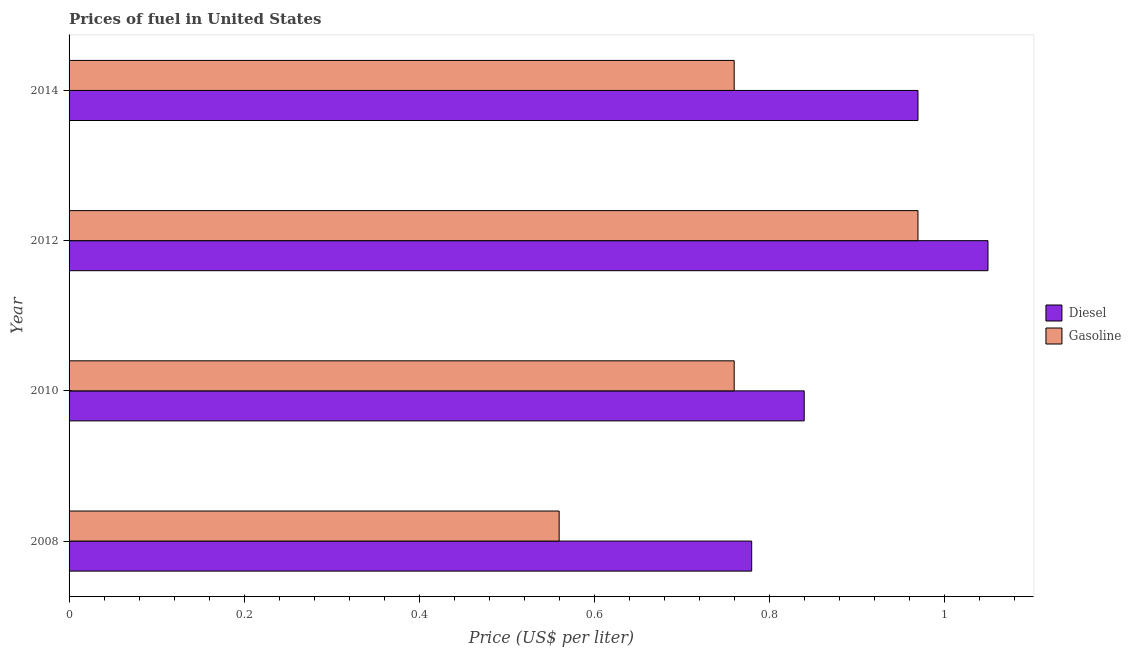How many different coloured bars are there?
Ensure brevity in your answer.  2. How many bars are there on the 2nd tick from the top?
Your answer should be compact. 2. How many bars are there on the 1st tick from the bottom?
Your answer should be compact. 2. What is the label of the 3rd group of bars from the top?
Provide a succinct answer. 2010. In how many cases, is the number of bars for a given year not equal to the number of legend labels?
Ensure brevity in your answer.  0. What is the diesel price in 2008?
Your response must be concise. 0.78. Across all years, what is the minimum diesel price?
Offer a terse response. 0.78. In which year was the gasoline price maximum?
Provide a short and direct response. 2012. In which year was the diesel price minimum?
Give a very brief answer. 2008. What is the total gasoline price in the graph?
Provide a succinct answer. 3.05. What is the difference between the diesel price in 2008 and that in 2010?
Your answer should be compact. -0.06. What is the difference between the diesel price in 2008 and the gasoline price in 2014?
Your answer should be compact. 0.02. What is the average gasoline price per year?
Your response must be concise. 0.76. In the year 2008, what is the difference between the diesel price and gasoline price?
Provide a short and direct response. 0.22. In how many years, is the diesel price greater than 0.36 US$ per litre?
Ensure brevity in your answer.  4. What is the ratio of the diesel price in 2012 to that in 2014?
Give a very brief answer. 1.08. Is the gasoline price in 2008 less than that in 2010?
Offer a very short reply. Yes. Is the difference between the diesel price in 2012 and 2014 greater than the difference between the gasoline price in 2012 and 2014?
Keep it short and to the point. No. What is the difference between the highest and the second highest gasoline price?
Keep it short and to the point. 0.21. What is the difference between the highest and the lowest diesel price?
Your answer should be compact. 0.27. Is the sum of the diesel price in 2008 and 2010 greater than the maximum gasoline price across all years?
Provide a succinct answer. Yes. What does the 1st bar from the top in 2008 represents?
Offer a very short reply. Gasoline. What does the 2nd bar from the bottom in 2012 represents?
Your answer should be compact. Gasoline. How many bars are there?
Give a very brief answer. 8. How many years are there in the graph?
Your response must be concise. 4. Does the graph contain any zero values?
Keep it short and to the point. No. Does the graph contain grids?
Offer a terse response. No. What is the title of the graph?
Your response must be concise. Prices of fuel in United States. Does "Female labor force" appear as one of the legend labels in the graph?
Offer a very short reply. No. What is the label or title of the X-axis?
Your response must be concise. Price (US$ per liter). What is the Price (US$ per liter) of Diesel in 2008?
Provide a succinct answer. 0.78. What is the Price (US$ per liter) of Gasoline in 2008?
Ensure brevity in your answer.  0.56. What is the Price (US$ per liter) of Diesel in 2010?
Provide a succinct answer. 0.84. What is the Price (US$ per liter) in Gasoline in 2010?
Ensure brevity in your answer.  0.76. What is the Price (US$ per liter) in Diesel in 2012?
Offer a very short reply. 1.05. What is the Price (US$ per liter) of Gasoline in 2014?
Offer a very short reply. 0.76. Across all years, what is the maximum Price (US$ per liter) in Diesel?
Provide a succinct answer. 1.05. Across all years, what is the minimum Price (US$ per liter) of Diesel?
Give a very brief answer. 0.78. Across all years, what is the minimum Price (US$ per liter) of Gasoline?
Your response must be concise. 0.56. What is the total Price (US$ per liter) of Diesel in the graph?
Provide a succinct answer. 3.64. What is the total Price (US$ per liter) in Gasoline in the graph?
Your response must be concise. 3.05. What is the difference between the Price (US$ per liter) in Diesel in 2008 and that in 2010?
Offer a very short reply. -0.06. What is the difference between the Price (US$ per liter) in Gasoline in 2008 and that in 2010?
Keep it short and to the point. -0.2. What is the difference between the Price (US$ per liter) of Diesel in 2008 and that in 2012?
Your response must be concise. -0.27. What is the difference between the Price (US$ per liter) of Gasoline in 2008 and that in 2012?
Your response must be concise. -0.41. What is the difference between the Price (US$ per liter) of Diesel in 2008 and that in 2014?
Offer a very short reply. -0.19. What is the difference between the Price (US$ per liter) in Diesel in 2010 and that in 2012?
Ensure brevity in your answer.  -0.21. What is the difference between the Price (US$ per liter) in Gasoline in 2010 and that in 2012?
Your answer should be compact. -0.21. What is the difference between the Price (US$ per liter) in Diesel in 2010 and that in 2014?
Your answer should be very brief. -0.13. What is the difference between the Price (US$ per liter) of Gasoline in 2010 and that in 2014?
Provide a succinct answer. 0. What is the difference between the Price (US$ per liter) in Diesel in 2012 and that in 2014?
Provide a succinct answer. 0.08. What is the difference between the Price (US$ per liter) in Gasoline in 2012 and that in 2014?
Offer a terse response. 0.21. What is the difference between the Price (US$ per liter) in Diesel in 2008 and the Price (US$ per liter) in Gasoline in 2012?
Offer a terse response. -0.19. What is the difference between the Price (US$ per liter) of Diesel in 2010 and the Price (US$ per liter) of Gasoline in 2012?
Your response must be concise. -0.13. What is the difference between the Price (US$ per liter) of Diesel in 2010 and the Price (US$ per liter) of Gasoline in 2014?
Provide a succinct answer. 0.08. What is the difference between the Price (US$ per liter) of Diesel in 2012 and the Price (US$ per liter) of Gasoline in 2014?
Your answer should be compact. 0.29. What is the average Price (US$ per liter) in Diesel per year?
Your answer should be compact. 0.91. What is the average Price (US$ per liter) in Gasoline per year?
Offer a very short reply. 0.76. In the year 2008, what is the difference between the Price (US$ per liter) of Diesel and Price (US$ per liter) of Gasoline?
Offer a very short reply. 0.22. In the year 2010, what is the difference between the Price (US$ per liter) in Diesel and Price (US$ per liter) in Gasoline?
Offer a terse response. 0.08. In the year 2012, what is the difference between the Price (US$ per liter) of Diesel and Price (US$ per liter) of Gasoline?
Offer a terse response. 0.08. In the year 2014, what is the difference between the Price (US$ per liter) of Diesel and Price (US$ per liter) of Gasoline?
Give a very brief answer. 0.21. What is the ratio of the Price (US$ per liter) of Gasoline in 2008 to that in 2010?
Keep it short and to the point. 0.74. What is the ratio of the Price (US$ per liter) in Diesel in 2008 to that in 2012?
Provide a succinct answer. 0.74. What is the ratio of the Price (US$ per liter) in Gasoline in 2008 to that in 2012?
Give a very brief answer. 0.58. What is the ratio of the Price (US$ per liter) of Diesel in 2008 to that in 2014?
Your answer should be very brief. 0.8. What is the ratio of the Price (US$ per liter) in Gasoline in 2008 to that in 2014?
Offer a very short reply. 0.74. What is the ratio of the Price (US$ per liter) of Diesel in 2010 to that in 2012?
Your answer should be compact. 0.8. What is the ratio of the Price (US$ per liter) of Gasoline in 2010 to that in 2012?
Provide a succinct answer. 0.78. What is the ratio of the Price (US$ per liter) in Diesel in 2010 to that in 2014?
Keep it short and to the point. 0.87. What is the ratio of the Price (US$ per liter) of Gasoline in 2010 to that in 2014?
Provide a succinct answer. 1. What is the ratio of the Price (US$ per liter) in Diesel in 2012 to that in 2014?
Offer a very short reply. 1.08. What is the ratio of the Price (US$ per liter) of Gasoline in 2012 to that in 2014?
Provide a short and direct response. 1.28. What is the difference between the highest and the second highest Price (US$ per liter) of Diesel?
Keep it short and to the point. 0.08. What is the difference between the highest and the second highest Price (US$ per liter) in Gasoline?
Offer a very short reply. 0.21. What is the difference between the highest and the lowest Price (US$ per liter) in Diesel?
Your answer should be very brief. 0.27. What is the difference between the highest and the lowest Price (US$ per liter) of Gasoline?
Give a very brief answer. 0.41. 